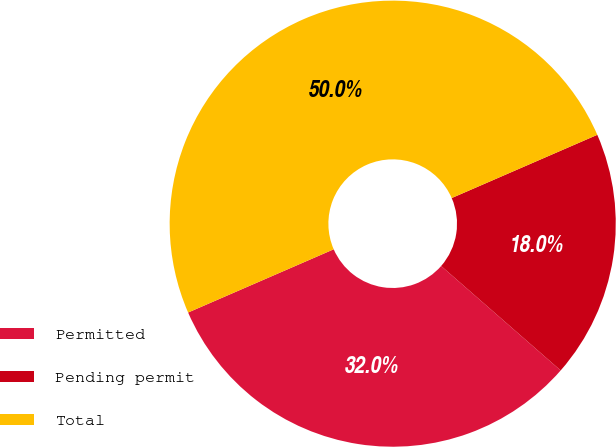Convert chart to OTSL. <chart><loc_0><loc_0><loc_500><loc_500><pie_chart><fcel>Permitted<fcel>Pending permit<fcel>Total<nl><fcel>32.05%<fcel>17.95%<fcel>50.0%<nl></chart> 